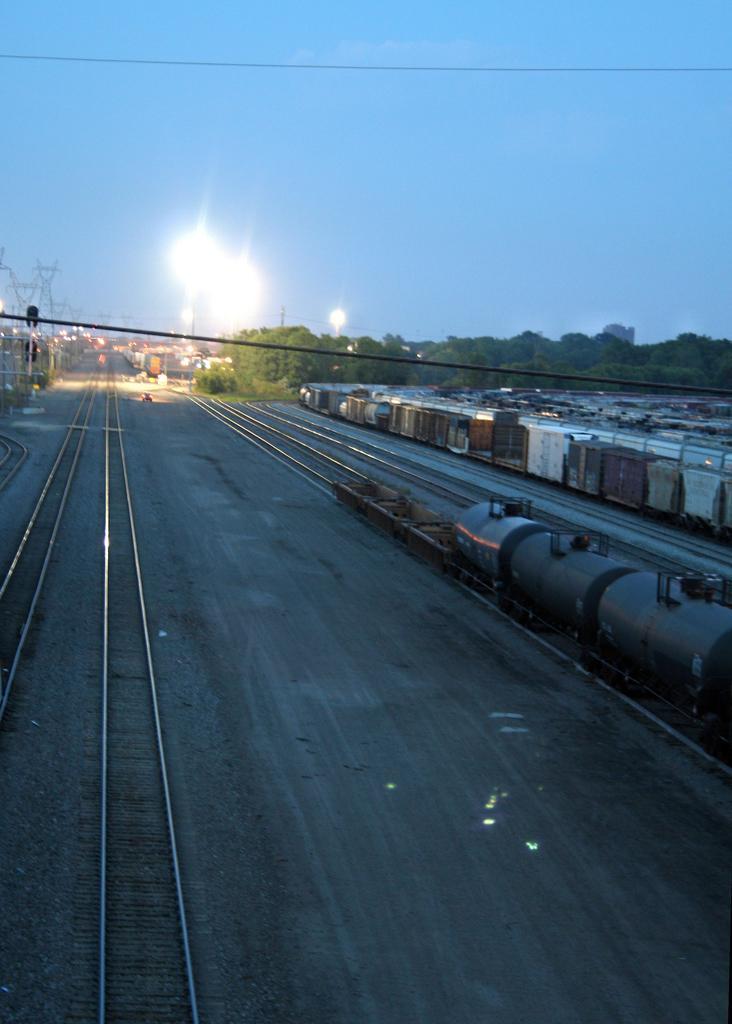Please provide a concise description of this image. In the image we can some tracks, on the tracks there are some locomotives. Behind the locomotives there are some trees and poles. At the top of the image there is sky. 